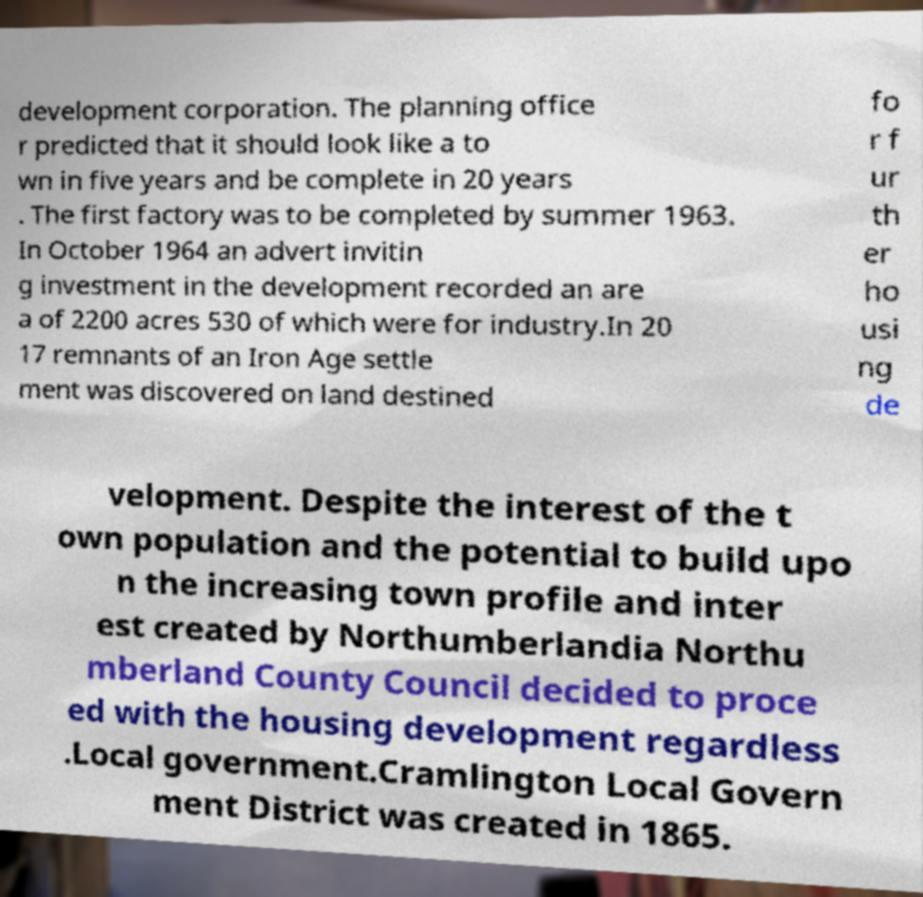Could you extract and type out the text from this image? development corporation. The planning office r predicted that it should look like a to wn in five years and be complete in 20 years . The first factory was to be completed by summer 1963. In October 1964 an advert invitin g investment in the development recorded an are a of 2200 acres 530 of which were for industry.In 20 17 remnants of an Iron Age settle ment was discovered on land destined fo r f ur th er ho usi ng de velopment. Despite the interest of the t own population and the potential to build upo n the increasing town profile and inter est created by Northumberlandia Northu mberland County Council decided to proce ed with the housing development regardless .Local government.Cramlington Local Govern ment District was created in 1865. 